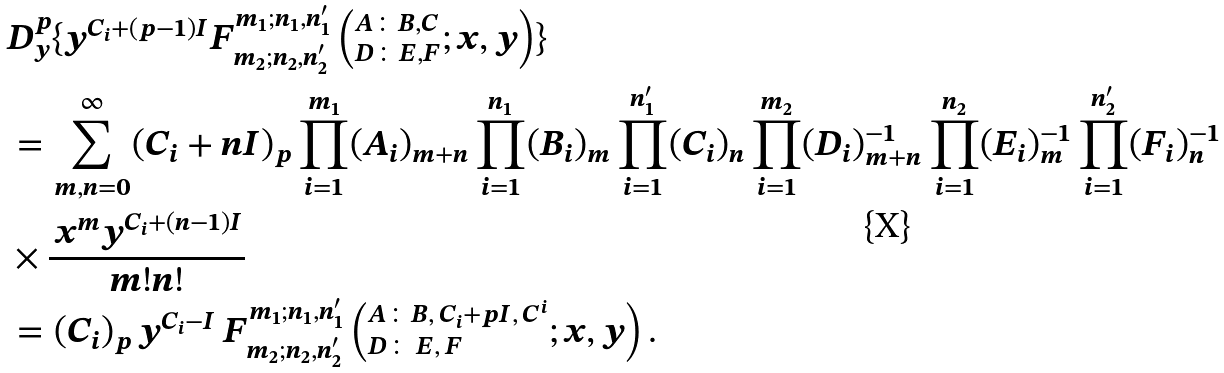Convert formula to latex. <formula><loc_0><loc_0><loc_500><loc_500>& D _ { y } ^ { p } \{ y ^ { C _ { i } + ( p - 1 ) I } F ^ { m _ { 1 } ; n _ { 1 } , n ^ { \prime } _ { 1 } } _ { m _ { 2 } ; n _ { 2 } , n ^ { \prime } _ { 2 } } \left ( ^ { A \colon B , C } _ { D \colon E , F } ; x , y \right ) \} \\ & = \sum _ { m , n = 0 } ^ { \infty } ( C _ { i } + n I ) _ { p } \prod _ { i = 1 } ^ { m _ { 1 } } ( A _ { i } ) _ { m + n } \prod _ { i = 1 } ^ { n _ { 1 } } ( B _ { i } ) _ { m } \prod _ { i = 1 } ^ { n ^ { \prime } _ { 1 } } ( C _ { i } ) _ { n } \prod _ { i = 1 } ^ { m _ { 2 } } ( D _ { i } ) ^ { - 1 } _ { m + n } \prod _ { i = 1 } ^ { n _ { 2 } } ( E _ { i } ) ^ { - 1 } _ { m } \prod _ { i = 1 } ^ { n ^ { \prime } _ { 2 } } ( F _ { i } ) ^ { - 1 } _ { n } \\ & \times \frac { \, x ^ { m } y ^ { C _ { i } + ( n - 1 ) I } } { m ! n ! } \\ & = ( C _ { i } ) _ { p } \, y ^ { C _ { i } - I } \, F ^ { m _ { 1 } ; n _ { 1 } , n ^ { \prime } _ { 1 } } _ { m _ { 2 } ; n _ { 2 } , n ^ { \prime } _ { 2 } } \left ( ^ { A \colon B , \, C _ { i } + p I , \, C ^ { i } } _ { D \colon \, E , \, F } ; x , y \right ) .</formula> 